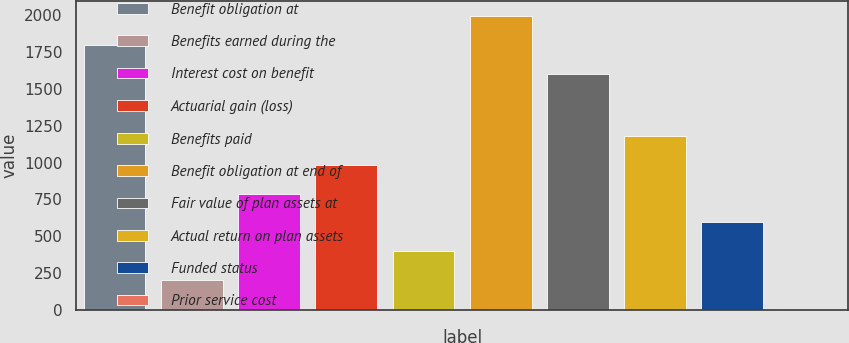Convert chart. <chart><loc_0><loc_0><loc_500><loc_500><bar_chart><fcel>Benefit obligation at<fcel>Benefits earned during the<fcel>Interest cost on benefit<fcel>Actuarial gain (loss)<fcel>Benefits paid<fcel>Benefit obligation at end of<fcel>Fair value of plan assets at<fcel>Actual return on plan assets<fcel>Funded status<fcel>Prior service cost<nl><fcel>1799.5<fcel>200.5<fcel>790<fcel>986.5<fcel>397<fcel>1996<fcel>1603<fcel>1183<fcel>593.5<fcel>4<nl></chart> 